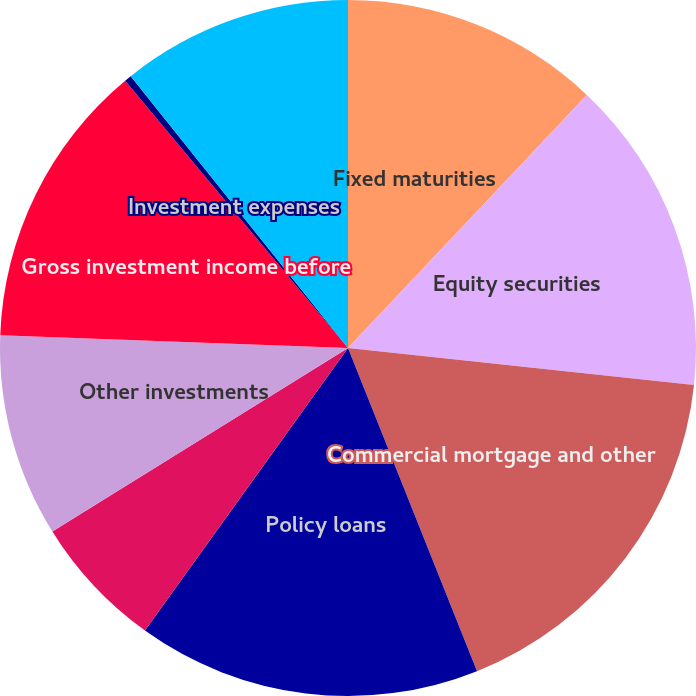Convert chart to OTSL. <chart><loc_0><loc_0><loc_500><loc_500><pie_chart><fcel>Fixed maturities<fcel>Equity securities<fcel>Commercial mortgage and other<fcel>Policy loans<fcel>Short-term investments and<fcel>Other investments<fcel>Gross investment income before<fcel>Investment expenses<fcel>Investment income after<nl><fcel>12.04%<fcel>14.65%<fcel>17.26%<fcel>15.96%<fcel>6.24%<fcel>9.43%<fcel>13.35%<fcel>0.33%<fcel>10.73%<nl></chart> 